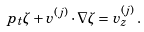Convert formula to latex. <formula><loc_0><loc_0><loc_500><loc_500>\ p _ { t } \zeta + { v } ^ { ( j ) } \cdot \nabla \zeta = { v } _ { z } ^ { ( j ) } \, .</formula> 